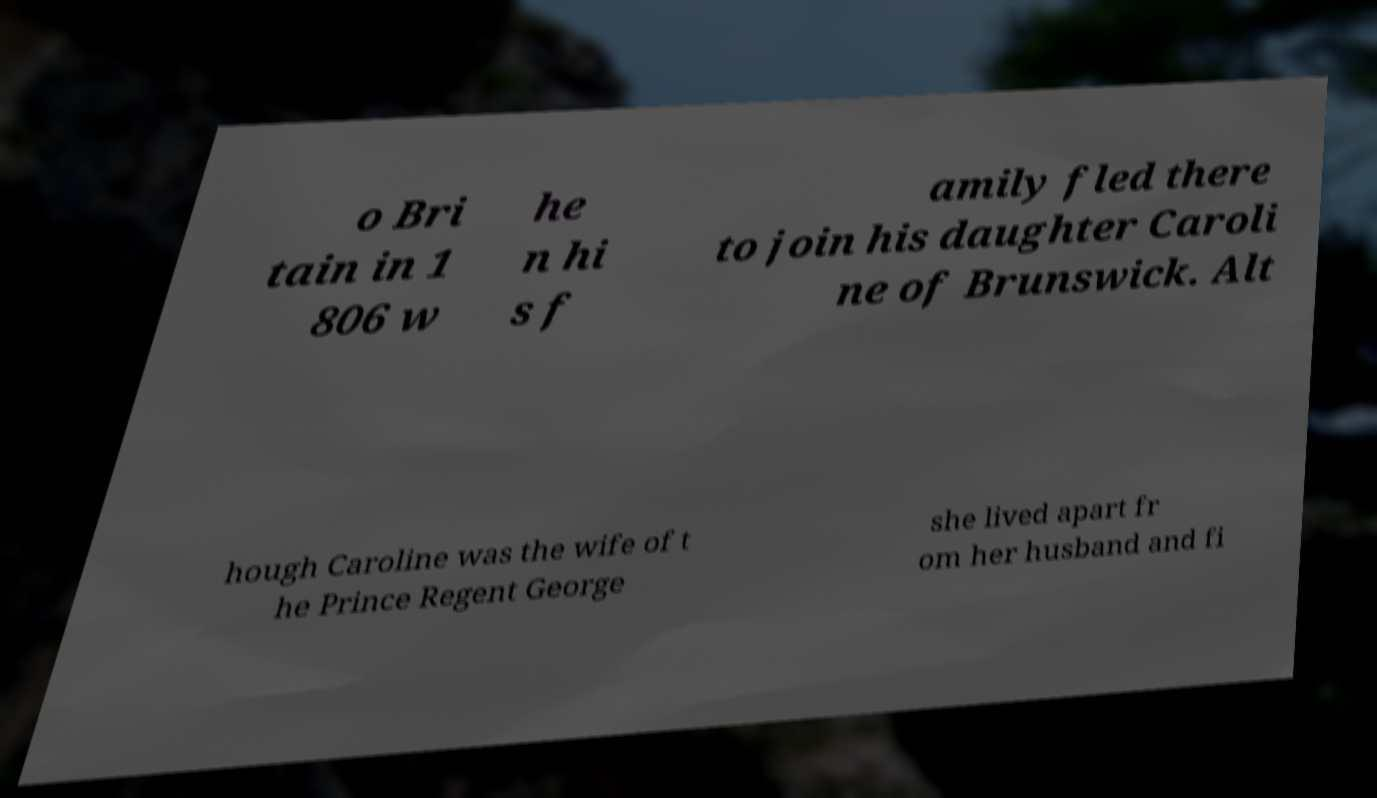Can you read and provide the text displayed in the image?This photo seems to have some interesting text. Can you extract and type it out for me? o Bri tain in 1 806 w he n hi s f amily fled there to join his daughter Caroli ne of Brunswick. Alt hough Caroline was the wife of t he Prince Regent George she lived apart fr om her husband and fi 